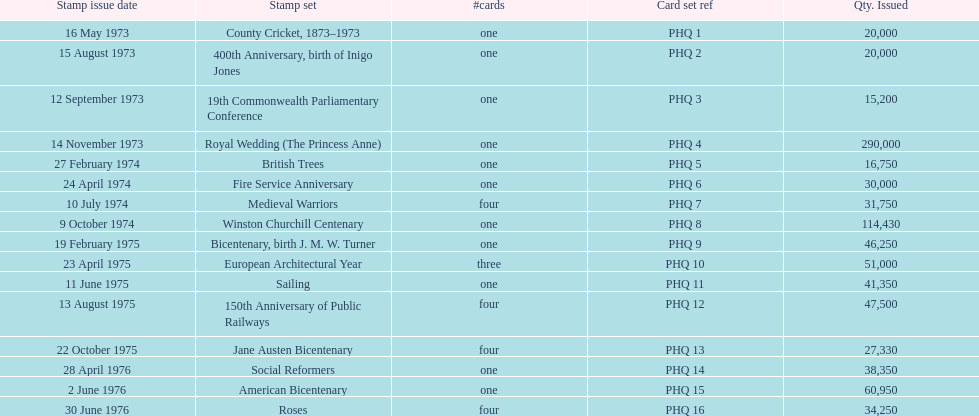How many stamp sets had a circulation of at least 50,000? 4. 